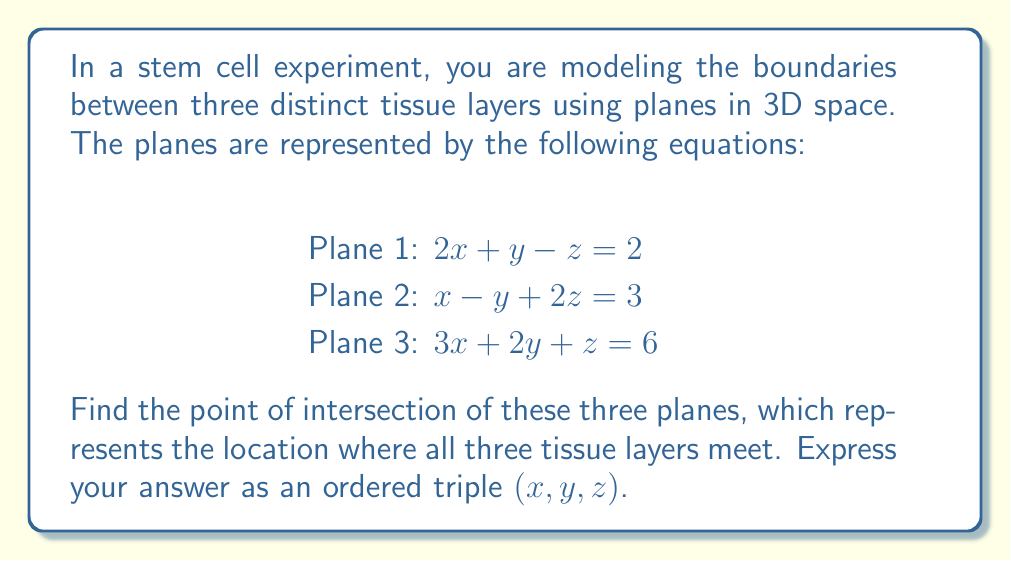Can you solve this math problem? To find the point of intersection of the three planes, we need to solve the system of linear equations:

$$\begin{align}
2x + y - z &= 2 \tag{1} \\
x - y + 2z &= 3 \tag{2} \\
3x + 2y + z &= 6 \tag{3}
\end{align}$$

We can solve this system using the elimination method:

1) Multiply equation (1) by 3 and equation (3) by -2:
   $$\begin{align}
   6x + 3y - 3z &= 6 \tag{4} \\
   -6x - 4y - 2z &= -12 \tag{5}
   \end{align}$$

2) Add equations (4) and (5):
   $$-y - 5z = -6 \tag{6}$$

3) Multiply equation (2) by 2:
   $$2x - 2y + 4z = 6 \tag{7}$$

4) Add equations (1) and (7):
   $$4x - y + 3z = 8 \tag{8}$$

5) Multiply equation (6) by 4 and add to equation (8):
   $$4x - 5y - 17z = -16 \tag{9}$$

6) Multiply equation (6) by 3 and subtract from equation (3):
   $$3x + 5y + 16z = 24 \tag{10}$$

7) Add equations (9) and (10):
   $$7x - z = 8 \tag{11}$$

8) From equation (11): $z = 7x - 8 \tag{12}$

9) Substitute (12) into equation (1):
   $$\begin{align}
   2x + y - (7x - 8) &= 2 \\
   -5x + y &= -6 \\
   y &= 5x - 6 \tag{13}
   \end{align}$$

10) Substitute (12) and (13) into equation (2):
    $$\begin{align}
    x - (5x - 6) + 2(7x - 8) &= 3 \\
    x - 5x + 6 + 14x - 16 &= 3 \\
    10x &= 13 \\
    x &= \frac{13}{10}
    \end{align}$$

11) Now we can find y and z:
    $$\begin{align}
    y &= 5(\frac{13}{10}) - 6 = \frac{5}{2} \\
    z &= 7(\frac{13}{10}) - 8 = \frac{11}{10}
    \end{align}$$

Therefore, the point of intersection is $(\frac{13}{10}, \frac{5}{2}, \frac{11}{10})$.
Answer: $(\frac{13}{10}, \frac{5}{2}, \frac{11}{10})$ 